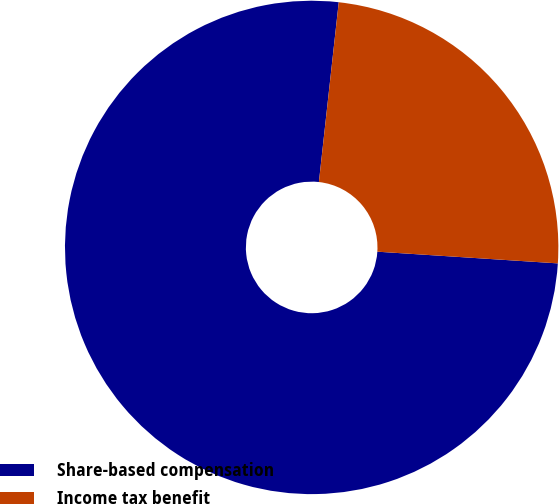<chart> <loc_0><loc_0><loc_500><loc_500><pie_chart><fcel>Share-based compensation<fcel>Income tax benefit<nl><fcel>75.72%<fcel>24.28%<nl></chart> 